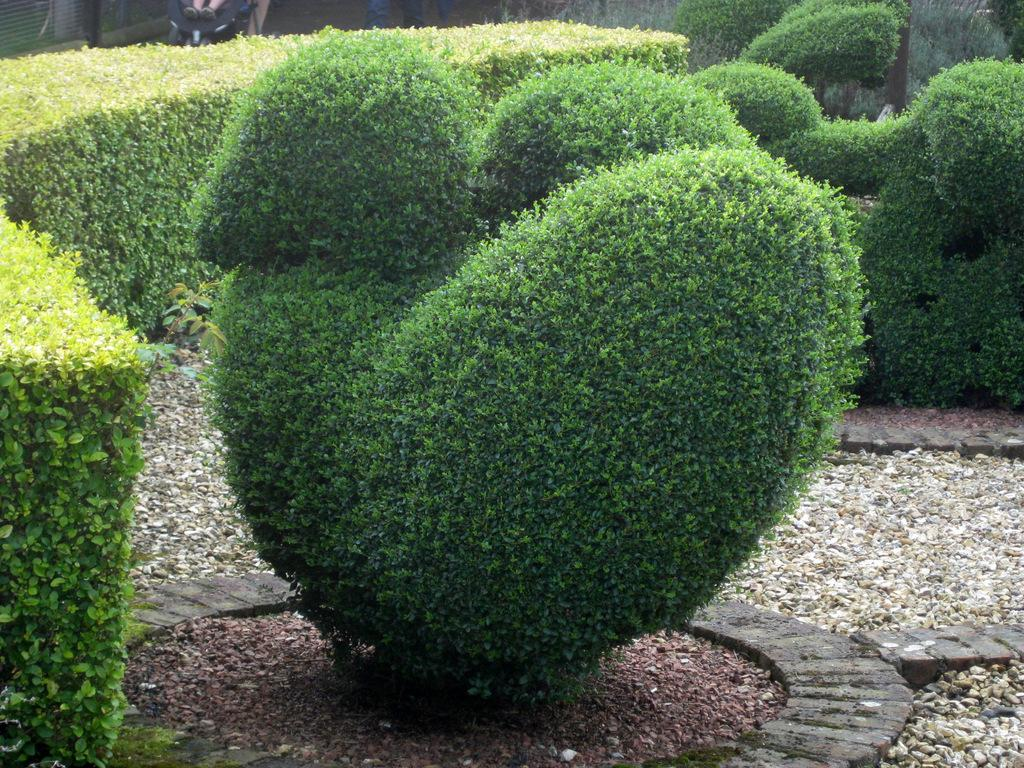What type of living organisms can be seen in the image? Plants can be seen in the image. What is present at the bottom of the image? There are stones and sand at the bottom of the image. Can you describe the background of the image? There are objects in the background of the image. What type of playground equipment can be seen in the image? There is no playground equipment present in the image. Can you tell me how many knives are visible in the image? There are no knives present in the image. 